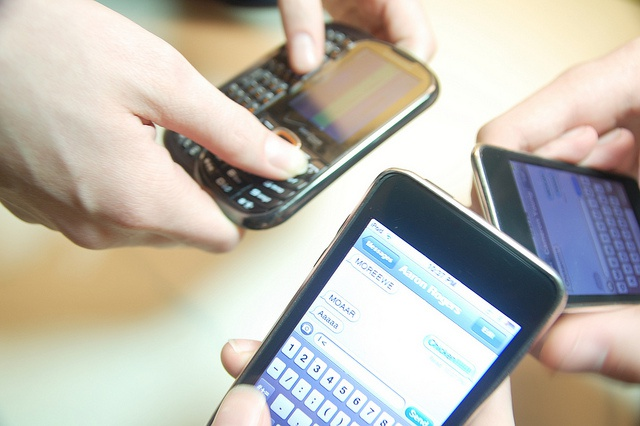Describe the objects in this image and their specific colors. I can see people in darkgray, ivory, lightgray, gray, and tan tones, cell phone in darkgray, white, darkblue, and lightblue tones, cell phone in darkgray, gray, tan, and black tones, people in darkgray, lightgray, tan, and brown tones, and cell phone in darkgray, gray, and purple tones in this image. 